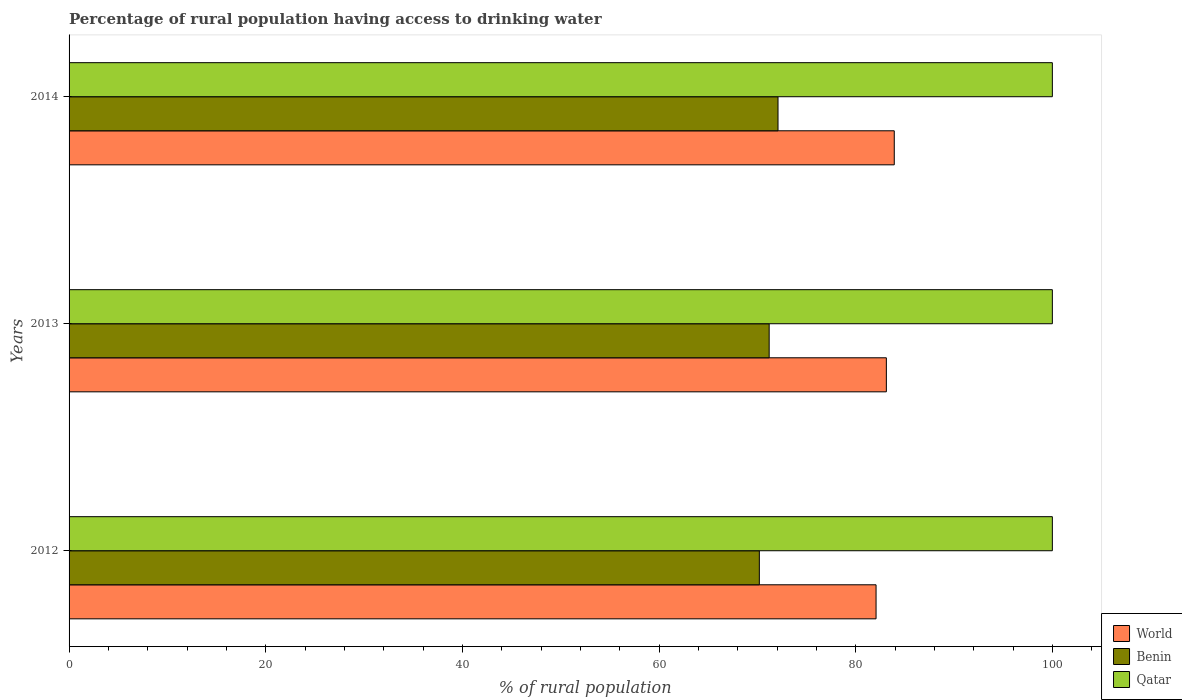How many different coloured bars are there?
Keep it short and to the point. 3. Are the number of bars per tick equal to the number of legend labels?
Provide a short and direct response. Yes. How many bars are there on the 1st tick from the top?
Your answer should be very brief. 3. What is the label of the 2nd group of bars from the top?
Ensure brevity in your answer.  2013. In how many cases, is the number of bars for a given year not equal to the number of legend labels?
Offer a terse response. 0. What is the percentage of rural population having access to drinking water in Benin in 2013?
Give a very brief answer. 71.2. Across all years, what is the maximum percentage of rural population having access to drinking water in Qatar?
Ensure brevity in your answer.  100. In which year was the percentage of rural population having access to drinking water in Qatar minimum?
Give a very brief answer. 2012. What is the total percentage of rural population having access to drinking water in Benin in the graph?
Make the answer very short. 213.5. What is the difference between the percentage of rural population having access to drinking water in World in 2014 and the percentage of rural population having access to drinking water in Benin in 2013?
Your response must be concise. 12.72. What is the average percentage of rural population having access to drinking water in World per year?
Offer a terse response. 83.04. In the year 2013, what is the difference between the percentage of rural population having access to drinking water in Benin and percentage of rural population having access to drinking water in Qatar?
Keep it short and to the point. -28.8. Is the percentage of rural population having access to drinking water in Benin in 2013 less than that in 2014?
Offer a terse response. Yes. Is the difference between the percentage of rural population having access to drinking water in Benin in 2013 and 2014 greater than the difference between the percentage of rural population having access to drinking water in Qatar in 2013 and 2014?
Make the answer very short. No. What is the difference between the highest and the second highest percentage of rural population having access to drinking water in Benin?
Provide a succinct answer. 0.9. What is the difference between the highest and the lowest percentage of rural population having access to drinking water in World?
Your response must be concise. 1.85. Is the sum of the percentage of rural population having access to drinking water in Qatar in 2012 and 2014 greater than the maximum percentage of rural population having access to drinking water in World across all years?
Provide a short and direct response. Yes. What does the 2nd bar from the top in 2012 represents?
Provide a short and direct response. Benin. What does the 2nd bar from the bottom in 2014 represents?
Your answer should be compact. Benin. Is it the case that in every year, the sum of the percentage of rural population having access to drinking water in World and percentage of rural population having access to drinking water in Qatar is greater than the percentage of rural population having access to drinking water in Benin?
Give a very brief answer. Yes. Are all the bars in the graph horizontal?
Your answer should be very brief. Yes. What is the difference between two consecutive major ticks on the X-axis?
Offer a very short reply. 20. Does the graph contain any zero values?
Give a very brief answer. No. How many legend labels are there?
Your answer should be very brief. 3. How are the legend labels stacked?
Your answer should be very brief. Vertical. What is the title of the graph?
Your answer should be compact. Percentage of rural population having access to drinking water. What is the label or title of the X-axis?
Keep it short and to the point. % of rural population. What is the % of rural population of World in 2012?
Your response must be concise. 82.07. What is the % of rural population in Benin in 2012?
Your answer should be very brief. 70.2. What is the % of rural population of Qatar in 2012?
Your answer should be very brief. 100. What is the % of rural population of World in 2013?
Your response must be concise. 83.12. What is the % of rural population in Benin in 2013?
Make the answer very short. 71.2. What is the % of rural population in Qatar in 2013?
Keep it short and to the point. 100. What is the % of rural population in World in 2014?
Keep it short and to the point. 83.92. What is the % of rural population in Benin in 2014?
Keep it short and to the point. 72.1. Across all years, what is the maximum % of rural population of World?
Keep it short and to the point. 83.92. Across all years, what is the maximum % of rural population of Benin?
Ensure brevity in your answer.  72.1. Across all years, what is the minimum % of rural population in World?
Your response must be concise. 82.07. Across all years, what is the minimum % of rural population in Benin?
Provide a short and direct response. 70.2. What is the total % of rural population of World in the graph?
Offer a very short reply. 249.11. What is the total % of rural population of Benin in the graph?
Give a very brief answer. 213.5. What is the total % of rural population of Qatar in the graph?
Your answer should be very brief. 300. What is the difference between the % of rural population in World in 2012 and that in 2013?
Offer a terse response. -1.05. What is the difference between the % of rural population of Benin in 2012 and that in 2013?
Provide a succinct answer. -1. What is the difference between the % of rural population in World in 2012 and that in 2014?
Provide a short and direct response. -1.85. What is the difference between the % of rural population in Benin in 2012 and that in 2014?
Provide a succinct answer. -1.9. What is the difference between the % of rural population in World in 2013 and that in 2014?
Give a very brief answer. -0.8. What is the difference between the % of rural population of Qatar in 2013 and that in 2014?
Offer a very short reply. 0. What is the difference between the % of rural population in World in 2012 and the % of rural population in Benin in 2013?
Your answer should be compact. 10.87. What is the difference between the % of rural population in World in 2012 and the % of rural population in Qatar in 2013?
Make the answer very short. -17.93. What is the difference between the % of rural population of Benin in 2012 and the % of rural population of Qatar in 2013?
Give a very brief answer. -29.8. What is the difference between the % of rural population in World in 2012 and the % of rural population in Benin in 2014?
Your response must be concise. 9.97. What is the difference between the % of rural population of World in 2012 and the % of rural population of Qatar in 2014?
Offer a terse response. -17.93. What is the difference between the % of rural population of Benin in 2012 and the % of rural population of Qatar in 2014?
Provide a succinct answer. -29.8. What is the difference between the % of rural population of World in 2013 and the % of rural population of Benin in 2014?
Provide a short and direct response. 11.02. What is the difference between the % of rural population of World in 2013 and the % of rural population of Qatar in 2014?
Keep it short and to the point. -16.88. What is the difference between the % of rural population of Benin in 2013 and the % of rural population of Qatar in 2014?
Make the answer very short. -28.8. What is the average % of rural population of World per year?
Provide a short and direct response. 83.04. What is the average % of rural population of Benin per year?
Offer a terse response. 71.17. In the year 2012, what is the difference between the % of rural population in World and % of rural population in Benin?
Your answer should be compact. 11.87. In the year 2012, what is the difference between the % of rural population of World and % of rural population of Qatar?
Offer a terse response. -17.93. In the year 2012, what is the difference between the % of rural population of Benin and % of rural population of Qatar?
Offer a very short reply. -29.8. In the year 2013, what is the difference between the % of rural population of World and % of rural population of Benin?
Keep it short and to the point. 11.92. In the year 2013, what is the difference between the % of rural population in World and % of rural population in Qatar?
Make the answer very short. -16.88. In the year 2013, what is the difference between the % of rural population of Benin and % of rural population of Qatar?
Make the answer very short. -28.8. In the year 2014, what is the difference between the % of rural population in World and % of rural population in Benin?
Make the answer very short. 11.82. In the year 2014, what is the difference between the % of rural population of World and % of rural population of Qatar?
Offer a terse response. -16.08. In the year 2014, what is the difference between the % of rural population in Benin and % of rural population in Qatar?
Ensure brevity in your answer.  -27.9. What is the ratio of the % of rural population in World in 2012 to that in 2013?
Your response must be concise. 0.99. What is the ratio of the % of rural population in Qatar in 2012 to that in 2013?
Your response must be concise. 1. What is the ratio of the % of rural population of World in 2012 to that in 2014?
Make the answer very short. 0.98. What is the ratio of the % of rural population of Benin in 2012 to that in 2014?
Offer a very short reply. 0.97. What is the ratio of the % of rural population of Benin in 2013 to that in 2014?
Provide a short and direct response. 0.99. What is the difference between the highest and the second highest % of rural population in World?
Make the answer very short. 0.8. What is the difference between the highest and the lowest % of rural population in World?
Your answer should be very brief. 1.85. What is the difference between the highest and the lowest % of rural population of Benin?
Your response must be concise. 1.9. What is the difference between the highest and the lowest % of rural population in Qatar?
Ensure brevity in your answer.  0. 